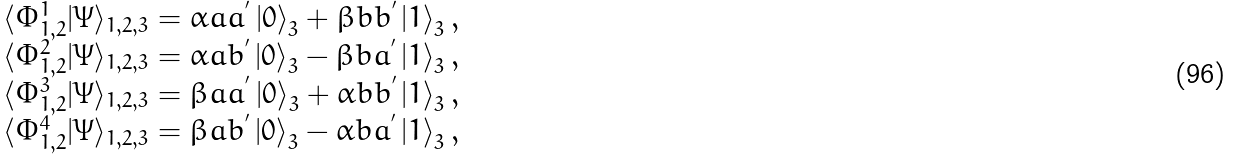<formula> <loc_0><loc_0><loc_500><loc_500>\begin{array} { c } \langle \Phi _ { 1 , 2 } ^ { 1 } | \Psi \rangle _ { 1 , 2 , 3 } = \alpha a a ^ { ^ { \prime } } \left | 0 \right \rangle _ { 3 } + \beta b b ^ { ^ { \prime } } \left | 1 \right \rangle _ { 3 } , \\ \langle \Phi _ { 1 , 2 } ^ { 2 } | \Psi \rangle _ { 1 , 2 , 3 } = \alpha a b ^ { ^ { \prime } } \left | 0 \right \rangle _ { 3 } - \beta b a ^ { ^ { \prime } } \left | 1 \right \rangle _ { 3 } , \\ \langle \Phi _ { 1 , 2 } ^ { 3 } | \Psi \rangle _ { 1 , 2 , 3 } = \beta a a ^ { ^ { \prime } } \left | 0 \right \rangle _ { 3 } + \alpha b b ^ { ^ { \prime } } \left | 1 \right \rangle _ { 3 } , \\ \langle \Phi _ { 1 , 2 } ^ { 4 } | \Psi \rangle _ { 1 , 2 , 3 } = \beta a b ^ { ^ { \prime } } \left | 0 \right \rangle _ { 3 } - \alpha b a ^ { ^ { \prime } } \left | 1 \right \rangle _ { 3 } , \end{array}</formula> 